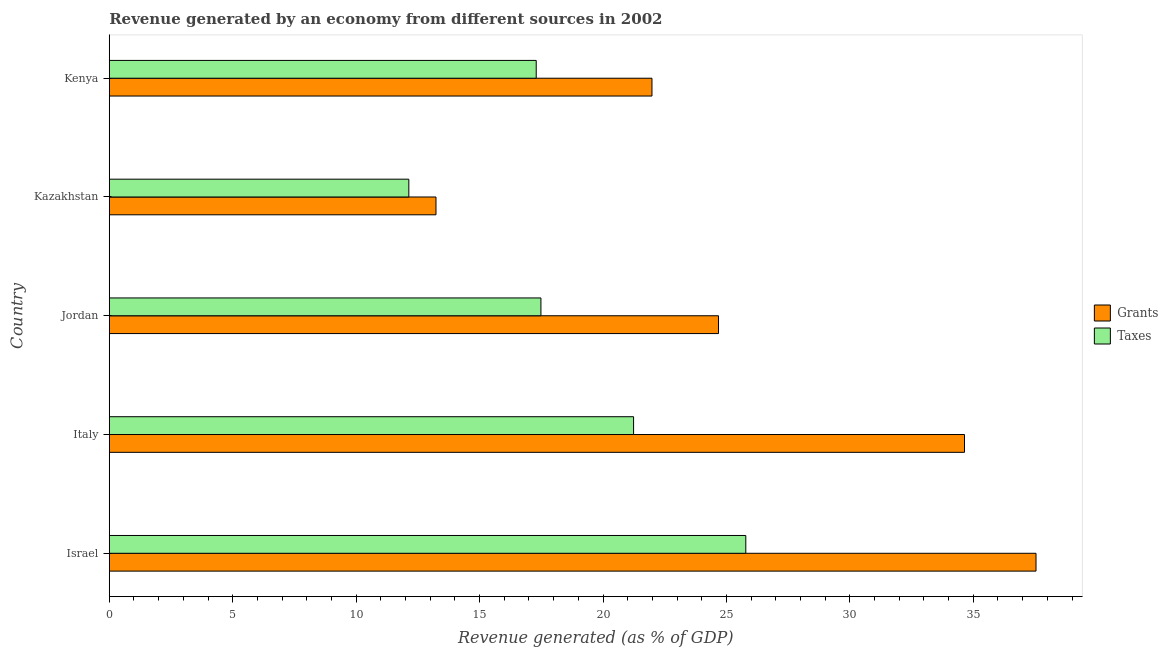How many different coloured bars are there?
Ensure brevity in your answer.  2. Are the number of bars on each tick of the Y-axis equal?
Ensure brevity in your answer.  Yes. How many bars are there on the 1st tick from the bottom?
Provide a succinct answer. 2. What is the revenue generated by taxes in Italy?
Offer a terse response. 21.24. Across all countries, what is the maximum revenue generated by grants?
Your answer should be very brief. 37.54. Across all countries, what is the minimum revenue generated by taxes?
Offer a very short reply. 12.13. In which country was the revenue generated by taxes maximum?
Keep it short and to the point. Israel. In which country was the revenue generated by taxes minimum?
Ensure brevity in your answer.  Kazakhstan. What is the total revenue generated by taxes in the graph?
Make the answer very short. 93.94. What is the difference between the revenue generated by grants in Israel and that in Kazakhstan?
Give a very brief answer. 24.31. What is the difference between the revenue generated by grants in Israel and the revenue generated by taxes in Jordan?
Give a very brief answer. 20.06. What is the average revenue generated by grants per country?
Make the answer very short. 26.42. What is the difference between the revenue generated by grants and revenue generated by taxes in Israel?
Give a very brief answer. 11.76. What is the difference between the highest and the second highest revenue generated by taxes?
Give a very brief answer. 4.55. What is the difference between the highest and the lowest revenue generated by taxes?
Provide a succinct answer. 13.65. In how many countries, is the revenue generated by taxes greater than the average revenue generated by taxes taken over all countries?
Offer a terse response. 2. Is the sum of the revenue generated by taxes in Jordan and Kazakhstan greater than the maximum revenue generated by grants across all countries?
Your answer should be very brief. No. What does the 1st bar from the top in Italy represents?
Offer a very short reply. Taxes. What does the 1st bar from the bottom in Kenya represents?
Your response must be concise. Grants. How many countries are there in the graph?
Make the answer very short. 5. What is the difference between two consecutive major ticks on the X-axis?
Give a very brief answer. 5. Does the graph contain any zero values?
Make the answer very short. No. Does the graph contain grids?
Make the answer very short. No. How are the legend labels stacked?
Offer a very short reply. Vertical. What is the title of the graph?
Your answer should be compact. Revenue generated by an economy from different sources in 2002. Does "Non-solid fuel" appear as one of the legend labels in the graph?
Make the answer very short. No. What is the label or title of the X-axis?
Provide a succinct answer. Revenue generated (as % of GDP). What is the Revenue generated (as % of GDP) of Grants in Israel?
Make the answer very short. 37.54. What is the Revenue generated (as % of GDP) in Taxes in Israel?
Your answer should be compact. 25.78. What is the Revenue generated (as % of GDP) of Grants in Italy?
Keep it short and to the point. 34.64. What is the Revenue generated (as % of GDP) of Taxes in Italy?
Your response must be concise. 21.24. What is the Revenue generated (as % of GDP) in Grants in Jordan?
Your answer should be compact. 24.68. What is the Revenue generated (as % of GDP) of Taxes in Jordan?
Keep it short and to the point. 17.49. What is the Revenue generated (as % of GDP) of Grants in Kazakhstan?
Offer a terse response. 13.23. What is the Revenue generated (as % of GDP) of Taxes in Kazakhstan?
Offer a very short reply. 12.13. What is the Revenue generated (as % of GDP) in Grants in Kenya?
Keep it short and to the point. 21.98. What is the Revenue generated (as % of GDP) of Taxes in Kenya?
Provide a short and direct response. 17.29. Across all countries, what is the maximum Revenue generated (as % of GDP) in Grants?
Offer a terse response. 37.54. Across all countries, what is the maximum Revenue generated (as % of GDP) of Taxes?
Ensure brevity in your answer.  25.78. Across all countries, what is the minimum Revenue generated (as % of GDP) of Grants?
Make the answer very short. 13.23. Across all countries, what is the minimum Revenue generated (as % of GDP) in Taxes?
Make the answer very short. 12.13. What is the total Revenue generated (as % of GDP) of Grants in the graph?
Provide a succinct answer. 132.08. What is the total Revenue generated (as % of GDP) in Taxes in the graph?
Provide a succinct answer. 93.94. What is the difference between the Revenue generated (as % of GDP) of Grants in Israel and that in Italy?
Give a very brief answer. 2.9. What is the difference between the Revenue generated (as % of GDP) of Taxes in Israel and that in Italy?
Offer a terse response. 4.55. What is the difference between the Revenue generated (as % of GDP) of Grants in Israel and that in Jordan?
Your answer should be compact. 12.86. What is the difference between the Revenue generated (as % of GDP) in Taxes in Israel and that in Jordan?
Your response must be concise. 8.3. What is the difference between the Revenue generated (as % of GDP) of Grants in Israel and that in Kazakhstan?
Offer a terse response. 24.31. What is the difference between the Revenue generated (as % of GDP) of Taxes in Israel and that in Kazakhstan?
Ensure brevity in your answer.  13.65. What is the difference between the Revenue generated (as % of GDP) of Grants in Israel and that in Kenya?
Offer a terse response. 15.56. What is the difference between the Revenue generated (as % of GDP) of Taxes in Israel and that in Kenya?
Offer a terse response. 8.49. What is the difference between the Revenue generated (as % of GDP) in Grants in Italy and that in Jordan?
Your answer should be compact. 9.96. What is the difference between the Revenue generated (as % of GDP) in Taxes in Italy and that in Jordan?
Make the answer very short. 3.75. What is the difference between the Revenue generated (as % of GDP) of Grants in Italy and that in Kazakhstan?
Offer a very short reply. 21.41. What is the difference between the Revenue generated (as % of GDP) in Taxes in Italy and that in Kazakhstan?
Provide a succinct answer. 9.1. What is the difference between the Revenue generated (as % of GDP) of Grants in Italy and that in Kenya?
Keep it short and to the point. 12.66. What is the difference between the Revenue generated (as % of GDP) in Taxes in Italy and that in Kenya?
Ensure brevity in your answer.  3.94. What is the difference between the Revenue generated (as % of GDP) in Grants in Jordan and that in Kazakhstan?
Provide a succinct answer. 11.45. What is the difference between the Revenue generated (as % of GDP) in Taxes in Jordan and that in Kazakhstan?
Provide a succinct answer. 5.35. What is the difference between the Revenue generated (as % of GDP) in Grants in Jordan and that in Kenya?
Offer a very short reply. 2.7. What is the difference between the Revenue generated (as % of GDP) in Taxes in Jordan and that in Kenya?
Your answer should be very brief. 0.19. What is the difference between the Revenue generated (as % of GDP) in Grants in Kazakhstan and that in Kenya?
Your response must be concise. -8.75. What is the difference between the Revenue generated (as % of GDP) of Taxes in Kazakhstan and that in Kenya?
Your answer should be compact. -5.16. What is the difference between the Revenue generated (as % of GDP) in Grants in Israel and the Revenue generated (as % of GDP) in Taxes in Italy?
Offer a very short reply. 16.3. What is the difference between the Revenue generated (as % of GDP) in Grants in Israel and the Revenue generated (as % of GDP) in Taxes in Jordan?
Your response must be concise. 20.06. What is the difference between the Revenue generated (as % of GDP) in Grants in Israel and the Revenue generated (as % of GDP) in Taxes in Kazakhstan?
Your answer should be very brief. 25.41. What is the difference between the Revenue generated (as % of GDP) in Grants in Israel and the Revenue generated (as % of GDP) in Taxes in Kenya?
Offer a terse response. 20.25. What is the difference between the Revenue generated (as % of GDP) in Grants in Italy and the Revenue generated (as % of GDP) in Taxes in Jordan?
Your answer should be very brief. 17.16. What is the difference between the Revenue generated (as % of GDP) of Grants in Italy and the Revenue generated (as % of GDP) of Taxes in Kazakhstan?
Keep it short and to the point. 22.51. What is the difference between the Revenue generated (as % of GDP) of Grants in Italy and the Revenue generated (as % of GDP) of Taxes in Kenya?
Give a very brief answer. 17.35. What is the difference between the Revenue generated (as % of GDP) of Grants in Jordan and the Revenue generated (as % of GDP) of Taxes in Kazakhstan?
Your response must be concise. 12.55. What is the difference between the Revenue generated (as % of GDP) in Grants in Jordan and the Revenue generated (as % of GDP) in Taxes in Kenya?
Provide a short and direct response. 7.38. What is the difference between the Revenue generated (as % of GDP) in Grants in Kazakhstan and the Revenue generated (as % of GDP) in Taxes in Kenya?
Ensure brevity in your answer.  -4.06. What is the average Revenue generated (as % of GDP) of Grants per country?
Make the answer very short. 26.42. What is the average Revenue generated (as % of GDP) in Taxes per country?
Make the answer very short. 18.79. What is the difference between the Revenue generated (as % of GDP) in Grants and Revenue generated (as % of GDP) in Taxes in Israel?
Your response must be concise. 11.76. What is the difference between the Revenue generated (as % of GDP) in Grants and Revenue generated (as % of GDP) in Taxes in Italy?
Keep it short and to the point. 13.4. What is the difference between the Revenue generated (as % of GDP) of Grants and Revenue generated (as % of GDP) of Taxes in Jordan?
Keep it short and to the point. 7.19. What is the difference between the Revenue generated (as % of GDP) in Grants and Revenue generated (as % of GDP) in Taxes in Kenya?
Ensure brevity in your answer.  4.69. What is the ratio of the Revenue generated (as % of GDP) in Grants in Israel to that in Italy?
Provide a short and direct response. 1.08. What is the ratio of the Revenue generated (as % of GDP) of Taxes in Israel to that in Italy?
Provide a short and direct response. 1.21. What is the ratio of the Revenue generated (as % of GDP) in Grants in Israel to that in Jordan?
Make the answer very short. 1.52. What is the ratio of the Revenue generated (as % of GDP) in Taxes in Israel to that in Jordan?
Provide a succinct answer. 1.47. What is the ratio of the Revenue generated (as % of GDP) in Grants in Israel to that in Kazakhstan?
Your response must be concise. 2.84. What is the ratio of the Revenue generated (as % of GDP) of Taxes in Israel to that in Kazakhstan?
Your answer should be very brief. 2.12. What is the ratio of the Revenue generated (as % of GDP) in Grants in Israel to that in Kenya?
Your answer should be compact. 1.71. What is the ratio of the Revenue generated (as % of GDP) of Taxes in Israel to that in Kenya?
Provide a succinct answer. 1.49. What is the ratio of the Revenue generated (as % of GDP) of Grants in Italy to that in Jordan?
Your answer should be very brief. 1.4. What is the ratio of the Revenue generated (as % of GDP) in Taxes in Italy to that in Jordan?
Your answer should be compact. 1.21. What is the ratio of the Revenue generated (as % of GDP) in Grants in Italy to that in Kazakhstan?
Ensure brevity in your answer.  2.62. What is the ratio of the Revenue generated (as % of GDP) in Taxes in Italy to that in Kazakhstan?
Your answer should be very brief. 1.75. What is the ratio of the Revenue generated (as % of GDP) in Grants in Italy to that in Kenya?
Provide a short and direct response. 1.58. What is the ratio of the Revenue generated (as % of GDP) of Taxes in Italy to that in Kenya?
Provide a short and direct response. 1.23. What is the ratio of the Revenue generated (as % of GDP) of Grants in Jordan to that in Kazakhstan?
Offer a terse response. 1.86. What is the ratio of the Revenue generated (as % of GDP) in Taxes in Jordan to that in Kazakhstan?
Ensure brevity in your answer.  1.44. What is the ratio of the Revenue generated (as % of GDP) of Grants in Jordan to that in Kenya?
Your answer should be compact. 1.12. What is the ratio of the Revenue generated (as % of GDP) in Grants in Kazakhstan to that in Kenya?
Your answer should be very brief. 0.6. What is the ratio of the Revenue generated (as % of GDP) in Taxes in Kazakhstan to that in Kenya?
Offer a very short reply. 0.7. What is the difference between the highest and the second highest Revenue generated (as % of GDP) in Grants?
Offer a very short reply. 2.9. What is the difference between the highest and the second highest Revenue generated (as % of GDP) of Taxes?
Your response must be concise. 4.55. What is the difference between the highest and the lowest Revenue generated (as % of GDP) in Grants?
Give a very brief answer. 24.31. What is the difference between the highest and the lowest Revenue generated (as % of GDP) of Taxes?
Offer a terse response. 13.65. 